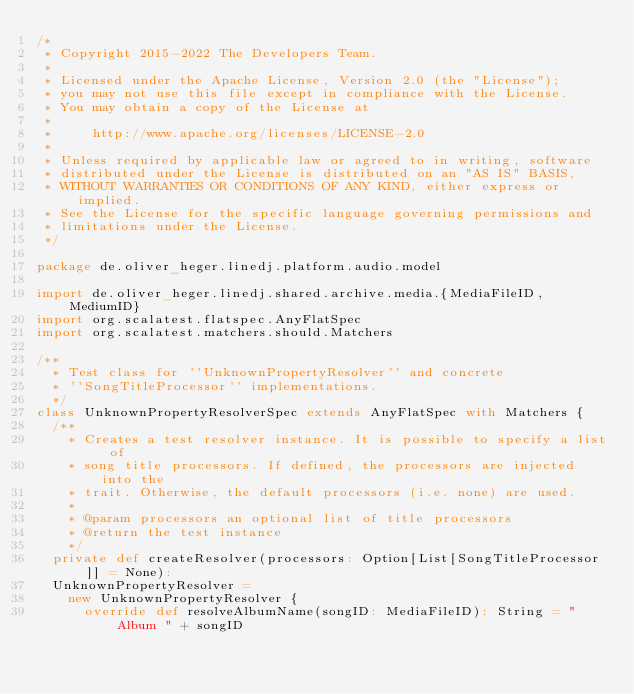Convert code to text. <code><loc_0><loc_0><loc_500><loc_500><_Scala_>/*
 * Copyright 2015-2022 The Developers Team.
 *
 * Licensed under the Apache License, Version 2.0 (the "License");
 * you may not use this file except in compliance with the License.
 * You may obtain a copy of the License at
 *
 *     http://www.apache.org/licenses/LICENSE-2.0
 *
 * Unless required by applicable law or agreed to in writing, software
 * distributed under the License is distributed on an "AS IS" BASIS,
 * WITHOUT WARRANTIES OR CONDITIONS OF ANY KIND, either express or implied.
 * See the License for the specific language governing permissions and
 * limitations under the License.
 */

package de.oliver_heger.linedj.platform.audio.model

import de.oliver_heger.linedj.shared.archive.media.{MediaFileID, MediumID}
import org.scalatest.flatspec.AnyFlatSpec
import org.scalatest.matchers.should.Matchers

/**
  * Test class for ''UnknownPropertyResolver'' and concrete
  * ''SongTitleProcessor'' implementations.
  */
class UnknownPropertyResolverSpec extends AnyFlatSpec with Matchers {
  /**
    * Creates a test resolver instance. It is possible to specify a list of
    * song title processors. If defined, the processors are injected into the
    * trait. Otherwise, the default processors (i.e. none) are used.
    *
    * @param processors an optional list of title processors
    * @return the test instance
    */
  private def createResolver(processors: Option[List[SongTitleProcessor]] = None):
  UnknownPropertyResolver =
    new UnknownPropertyResolver {
      override def resolveAlbumName(songID: MediaFileID): String = "Album " + songID
</code> 